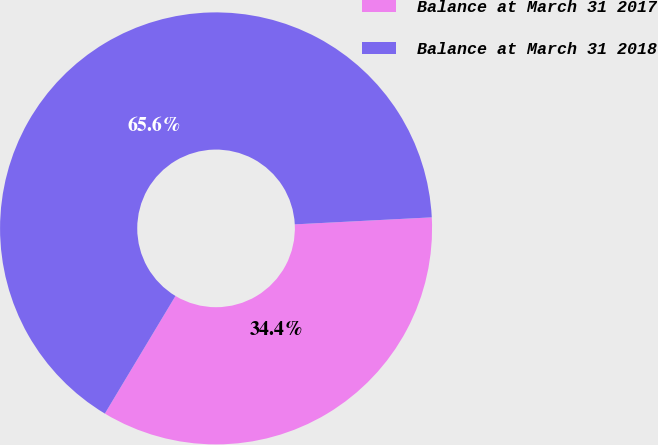Convert chart to OTSL. <chart><loc_0><loc_0><loc_500><loc_500><pie_chart><fcel>Balance at March 31 2017<fcel>Balance at March 31 2018<nl><fcel>34.42%<fcel>65.58%<nl></chart> 